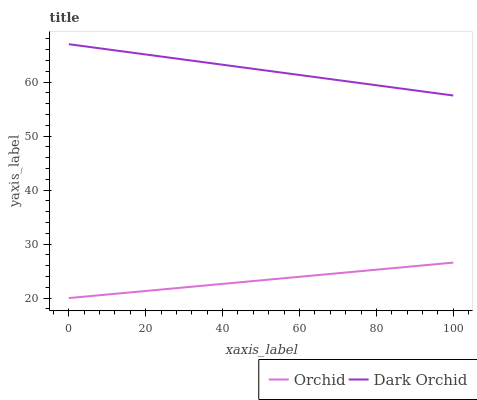Does Orchid have the minimum area under the curve?
Answer yes or no. Yes. Does Dark Orchid have the maximum area under the curve?
Answer yes or no. Yes. Does Orchid have the maximum area under the curve?
Answer yes or no. No. Is Orchid the smoothest?
Answer yes or no. Yes. Is Dark Orchid the roughest?
Answer yes or no. Yes. Is Orchid the roughest?
Answer yes or no. No. Does Orchid have the lowest value?
Answer yes or no. Yes. Does Dark Orchid have the highest value?
Answer yes or no. Yes. Does Orchid have the highest value?
Answer yes or no. No. Is Orchid less than Dark Orchid?
Answer yes or no. Yes. Is Dark Orchid greater than Orchid?
Answer yes or no. Yes. Does Orchid intersect Dark Orchid?
Answer yes or no. No. 